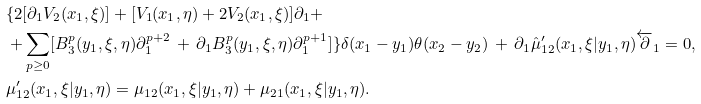<formula> <loc_0><loc_0><loc_500><loc_500>& \{ 2 [ \partial _ { 1 } V _ { 2 } ( x _ { 1 } , \xi ) ] + [ V _ { 1 } ( x _ { 1 } , \eta ) + 2 V _ { 2 } ( x _ { 1 } , \xi ) ] \partial _ { 1 } + \\ & + \sum _ { p \geq 0 } [ B _ { 3 } ^ { p } ( y _ { 1 } , \xi , \eta ) \partial _ { 1 } ^ { p + 2 } \, + \, \partial _ { 1 } B _ { 3 } ^ { p } ( y _ { 1 } , \xi , \eta ) \partial _ { 1 } ^ { p + 1 } ] \} \delta ( x _ { 1 } - y _ { 1 } ) \theta ( x _ { 2 } - y _ { 2 } ) \, + \, \partial _ { 1 } \hat { \mu } _ { 1 2 } ^ { \prime } ( x _ { 1 } , \xi | y _ { 1 } , \eta ) \overleftarrow { \partial } _ { 1 } = 0 , \\ & \mu _ { 1 2 } ^ { \prime } ( x _ { 1 } , \xi | y _ { 1 } , \eta ) = \mu _ { 1 2 } ( x _ { 1 } , \xi | y _ { 1 } , \eta ) + \mu _ { 2 1 } ( x _ { 1 } , \xi | y _ { 1 } , \eta ) .</formula> 